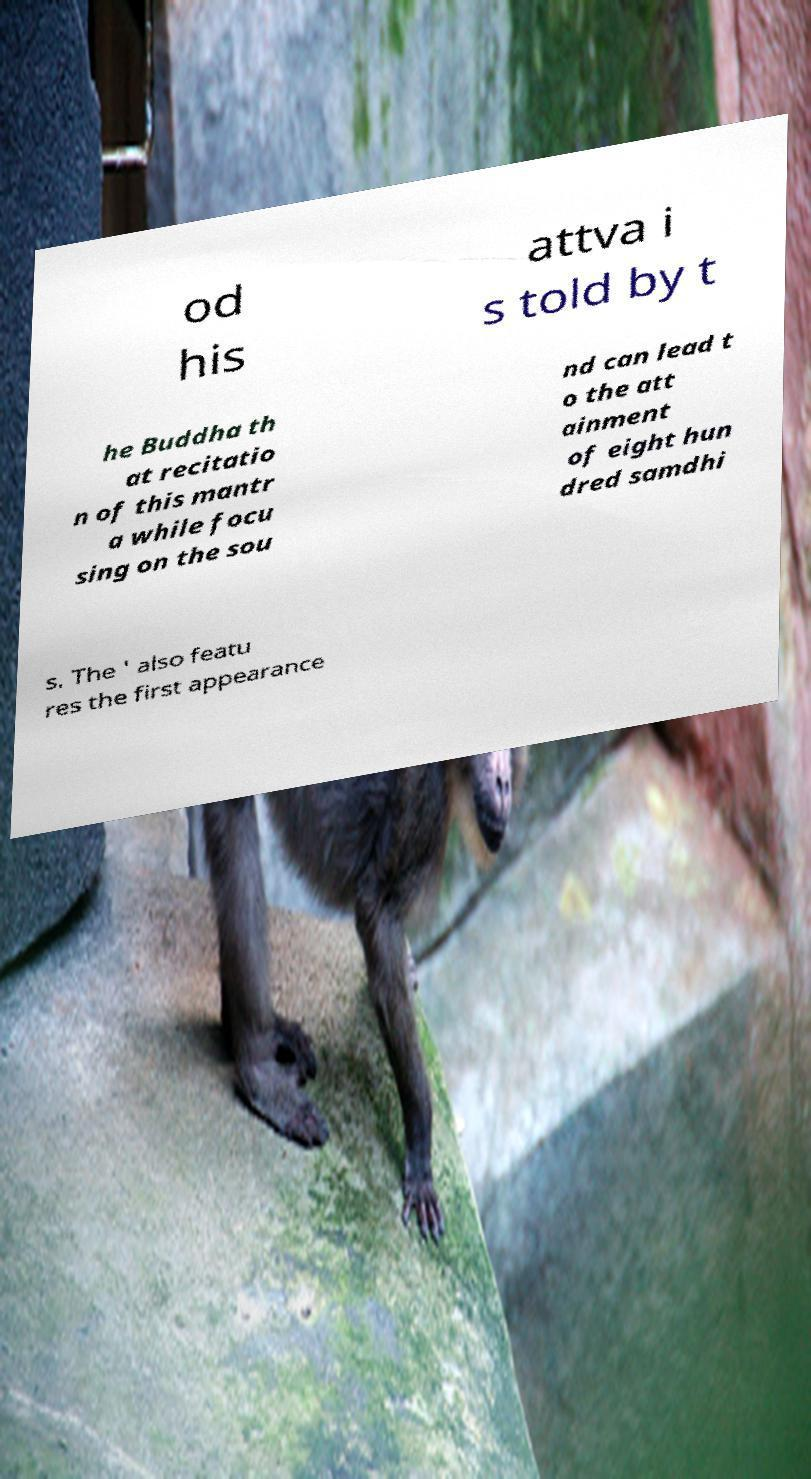Please read and relay the text visible in this image. What does it say? od his attva i s told by t he Buddha th at recitatio n of this mantr a while focu sing on the sou nd can lead t o the att ainment of eight hun dred samdhi s. The ' also featu res the first appearance 